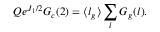<formula> <loc_0><loc_0><loc_500><loc_500>Q e ^ { J _ { 1 } / 2 } G _ { c } ( 2 ) = \langle l _ { g } \rangle \sum _ { l } G _ { g } ( l ) .</formula> 